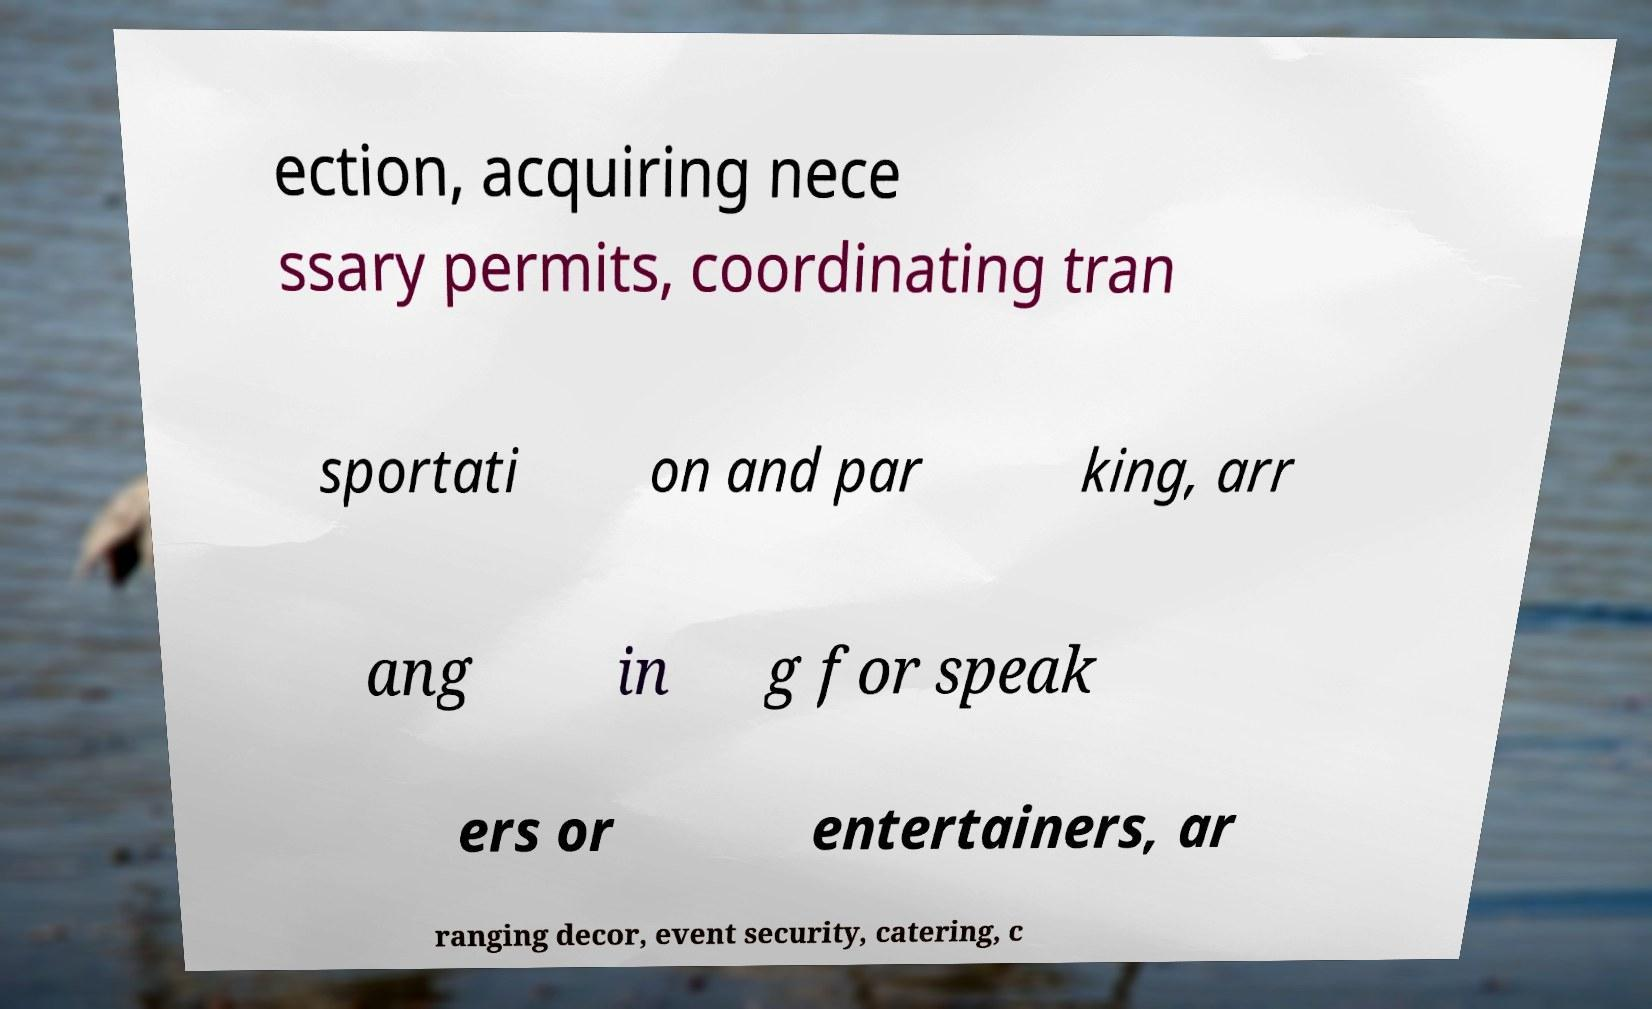I need the written content from this picture converted into text. Can you do that? ection, acquiring nece ssary permits, coordinating tran sportati on and par king, arr ang in g for speak ers or entertainers, ar ranging decor, event security, catering, c 